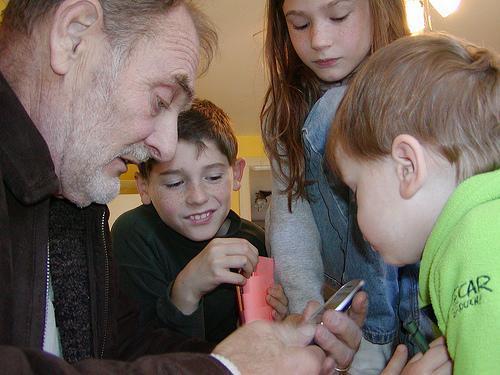How many adults are in the photo?
Give a very brief answer. 1. How many of the people in the image are children?
Give a very brief answer. 3. 